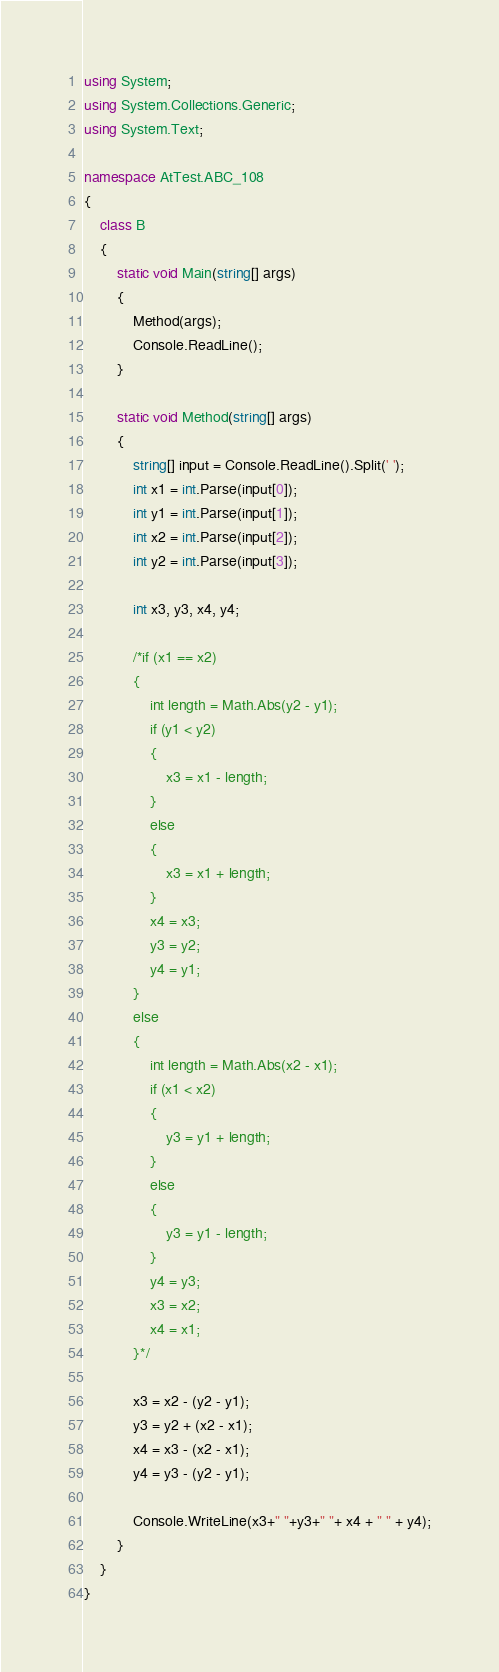Convert code to text. <code><loc_0><loc_0><loc_500><loc_500><_C#_>using System;
using System.Collections.Generic;
using System.Text;

namespace AtTest.ABC_108
{
    class B
    {
        static void Main(string[] args)
        {
            Method(args);
            Console.ReadLine();
        }

        static void Method(string[] args)
        {
            string[] input = Console.ReadLine().Split(' ');
            int x1 = int.Parse(input[0]);
            int y1 = int.Parse(input[1]);
            int x2 = int.Parse(input[2]);
            int y2 = int.Parse(input[3]);

            int x3, y3, x4, y4;

            /*if (x1 == x2)
            {
                int length = Math.Abs(y2 - y1);
                if (y1 < y2)
                {
                    x3 = x1 - length;
                }
                else
                {
                    x3 = x1 + length;
                }
                x4 = x3;
                y3 = y2;
                y4 = y1;
            }
            else
            {
                int length = Math.Abs(x2 - x1);
                if (x1 < x2)
                {
                    y3 = y1 + length;
                }
                else
                {
                    y3 = y1 - length;
                }
                y4 = y3;
                x3 = x2;
                x4 = x1;
            }*/

            x3 = x2 - (y2 - y1);
            y3 = y2 + (x2 - x1);
            x4 = x3 - (x2 - x1);
            y4 = y3 - (y2 - y1);

            Console.WriteLine(x3+" "+y3+" "+ x4 + " " + y4);
        }
    }
}
</code> 